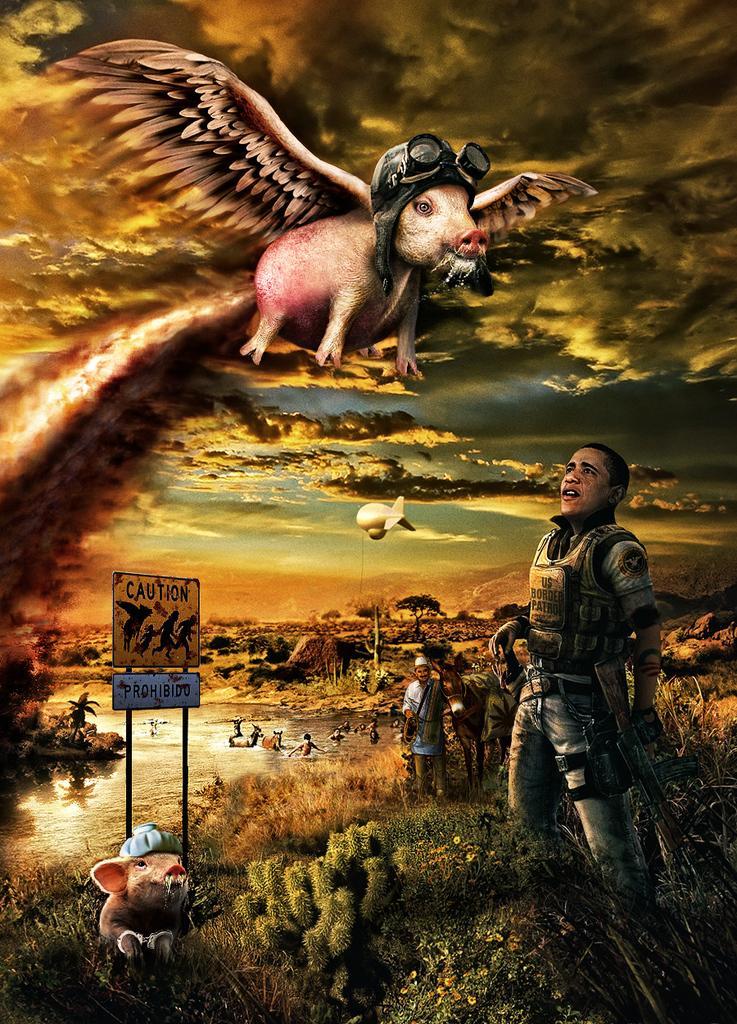Describe this image in one or two sentences. This is an animated image. In it we can see there are people wearing clothes. This is grass, Water, board, pole, animal, smoke and a cloudy sky. This is a rifle. 